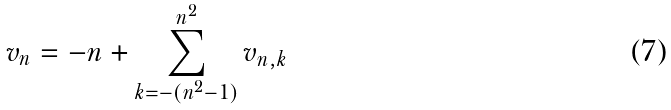<formula> <loc_0><loc_0><loc_500><loc_500>v _ { n } = - n + \sum _ { k = - ( n ^ { 2 } - 1 ) } ^ { n ^ { 2 } } v _ { n , k }</formula> 